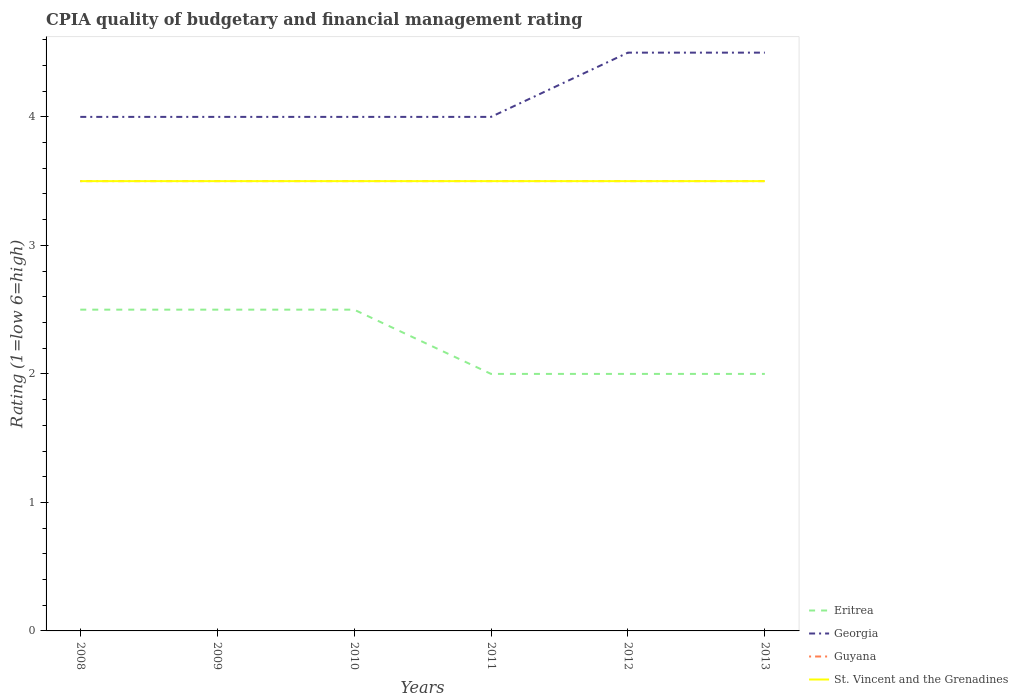How many different coloured lines are there?
Your answer should be very brief. 4. What is the total CPIA rating in Guyana in the graph?
Your response must be concise. 0. What is the difference between the highest and the lowest CPIA rating in Eritrea?
Your answer should be compact. 3. Is the CPIA rating in Guyana strictly greater than the CPIA rating in Eritrea over the years?
Keep it short and to the point. No. How many lines are there?
Keep it short and to the point. 4. Are the values on the major ticks of Y-axis written in scientific E-notation?
Offer a very short reply. No. Does the graph contain any zero values?
Your answer should be compact. No. Where does the legend appear in the graph?
Give a very brief answer. Bottom right. How many legend labels are there?
Provide a succinct answer. 4. What is the title of the graph?
Ensure brevity in your answer.  CPIA quality of budgetary and financial management rating. Does "Poland" appear as one of the legend labels in the graph?
Your answer should be very brief. No. What is the label or title of the X-axis?
Your response must be concise. Years. What is the Rating (1=low 6=high) in Eritrea in 2008?
Keep it short and to the point. 2.5. What is the Rating (1=low 6=high) of Georgia in 2008?
Keep it short and to the point. 4. What is the Rating (1=low 6=high) of Guyana in 2009?
Provide a succinct answer. 3.5. What is the Rating (1=low 6=high) of St. Vincent and the Grenadines in 2009?
Provide a succinct answer. 3.5. What is the Rating (1=low 6=high) of Eritrea in 2010?
Give a very brief answer. 2.5. What is the Rating (1=low 6=high) of Georgia in 2010?
Provide a succinct answer. 4. What is the Rating (1=low 6=high) of Guyana in 2010?
Your answer should be compact. 3.5. What is the Rating (1=low 6=high) of Eritrea in 2011?
Your answer should be very brief. 2. What is the Rating (1=low 6=high) of Guyana in 2011?
Your answer should be very brief. 3.5. What is the Rating (1=low 6=high) of St. Vincent and the Grenadines in 2012?
Offer a very short reply. 3.5. What is the Rating (1=low 6=high) of Eritrea in 2013?
Your answer should be very brief. 2. What is the Rating (1=low 6=high) in Guyana in 2013?
Keep it short and to the point. 3.5. What is the Rating (1=low 6=high) in St. Vincent and the Grenadines in 2013?
Your answer should be very brief. 3.5. Across all years, what is the maximum Rating (1=low 6=high) in Guyana?
Your response must be concise. 3.5. What is the difference between the Rating (1=low 6=high) of Georgia in 2008 and that in 2009?
Ensure brevity in your answer.  0. What is the difference between the Rating (1=low 6=high) in Guyana in 2008 and that in 2009?
Provide a succinct answer. 0. What is the difference between the Rating (1=low 6=high) in Eritrea in 2008 and that in 2010?
Provide a short and direct response. 0. What is the difference between the Rating (1=low 6=high) of Guyana in 2008 and that in 2010?
Give a very brief answer. 0. What is the difference between the Rating (1=low 6=high) of Eritrea in 2008 and that in 2011?
Provide a succinct answer. 0.5. What is the difference between the Rating (1=low 6=high) of Eritrea in 2008 and that in 2012?
Make the answer very short. 0.5. What is the difference between the Rating (1=low 6=high) in Georgia in 2008 and that in 2012?
Your answer should be compact. -0.5. What is the difference between the Rating (1=low 6=high) of Guyana in 2008 and that in 2012?
Offer a terse response. 0. What is the difference between the Rating (1=low 6=high) of St. Vincent and the Grenadines in 2008 and that in 2012?
Ensure brevity in your answer.  0. What is the difference between the Rating (1=low 6=high) in Georgia in 2008 and that in 2013?
Offer a very short reply. -0.5. What is the difference between the Rating (1=low 6=high) of Guyana in 2008 and that in 2013?
Your answer should be compact. 0. What is the difference between the Rating (1=low 6=high) in St. Vincent and the Grenadines in 2008 and that in 2013?
Your answer should be compact. 0. What is the difference between the Rating (1=low 6=high) of St. Vincent and the Grenadines in 2009 and that in 2010?
Offer a very short reply. 0. What is the difference between the Rating (1=low 6=high) in Guyana in 2009 and that in 2012?
Ensure brevity in your answer.  0. What is the difference between the Rating (1=low 6=high) of Eritrea in 2009 and that in 2013?
Provide a short and direct response. 0.5. What is the difference between the Rating (1=low 6=high) of Georgia in 2009 and that in 2013?
Ensure brevity in your answer.  -0.5. What is the difference between the Rating (1=low 6=high) in St. Vincent and the Grenadines in 2009 and that in 2013?
Offer a terse response. 0. What is the difference between the Rating (1=low 6=high) in Eritrea in 2010 and that in 2011?
Offer a terse response. 0.5. What is the difference between the Rating (1=low 6=high) in Georgia in 2010 and that in 2011?
Provide a succinct answer. 0. What is the difference between the Rating (1=low 6=high) in St. Vincent and the Grenadines in 2010 and that in 2011?
Give a very brief answer. 0. What is the difference between the Rating (1=low 6=high) of Eritrea in 2010 and that in 2012?
Provide a short and direct response. 0.5. What is the difference between the Rating (1=low 6=high) of Georgia in 2010 and that in 2012?
Offer a terse response. -0.5. What is the difference between the Rating (1=low 6=high) in St. Vincent and the Grenadines in 2010 and that in 2012?
Your answer should be very brief. 0. What is the difference between the Rating (1=low 6=high) in Guyana in 2010 and that in 2013?
Offer a terse response. 0. What is the difference between the Rating (1=low 6=high) in St. Vincent and the Grenadines in 2010 and that in 2013?
Keep it short and to the point. 0. What is the difference between the Rating (1=low 6=high) in Eritrea in 2011 and that in 2012?
Offer a very short reply. 0. What is the difference between the Rating (1=low 6=high) in Guyana in 2011 and that in 2012?
Offer a very short reply. 0. What is the difference between the Rating (1=low 6=high) of Eritrea in 2011 and that in 2013?
Offer a very short reply. 0. What is the difference between the Rating (1=low 6=high) in Georgia in 2011 and that in 2013?
Provide a short and direct response. -0.5. What is the difference between the Rating (1=low 6=high) of St. Vincent and the Grenadines in 2011 and that in 2013?
Provide a succinct answer. 0. What is the difference between the Rating (1=low 6=high) of Eritrea in 2012 and that in 2013?
Offer a terse response. 0. What is the difference between the Rating (1=low 6=high) in Georgia in 2012 and that in 2013?
Provide a succinct answer. 0. What is the difference between the Rating (1=low 6=high) of Eritrea in 2008 and the Rating (1=low 6=high) of Georgia in 2009?
Offer a terse response. -1.5. What is the difference between the Rating (1=low 6=high) in Eritrea in 2008 and the Rating (1=low 6=high) in Guyana in 2009?
Offer a very short reply. -1. What is the difference between the Rating (1=low 6=high) in Eritrea in 2008 and the Rating (1=low 6=high) in Georgia in 2010?
Provide a succinct answer. -1.5. What is the difference between the Rating (1=low 6=high) in Georgia in 2008 and the Rating (1=low 6=high) in Guyana in 2010?
Your answer should be very brief. 0.5. What is the difference between the Rating (1=low 6=high) in Georgia in 2008 and the Rating (1=low 6=high) in Guyana in 2011?
Your answer should be very brief. 0.5. What is the difference between the Rating (1=low 6=high) of Guyana in 2008 and the Rating (1=low 6=high) of St. Vincent and the Grenadines in 2011?
Provide a short and direct response. 0. What is the difference between the Rating (1=low 6=high) of Eritrea in 2008 and the Rating (1=low 6=high) of Georgia in 2012?
Your answer should be compact. -2. What is the difference between the Rating (1=low 6=high) of Eritrea in 2008 and the Rating (1=low 6=high) of St. Vincent and the Grenadines in 2012?
Provide a short and direct response. -1. What is the difference between the Rating (1=low 6=high) in Guyana in 2008 and the Rating (1=low 6=high) in St. Vincent and the Grenadines in 2012?
Offer a terse response. 0. What is the difference between the Rating (1=low 6=high) in Eritrea in 2008 and the Rating (1=low 6=high) in St. Vincent and the Grenadines in 2013?
Your answer should be compact. -1. What is the difference between the Rating (1=low 6=high) of Guyana in 2008 and the Rating (1=low 6=high) of St. Vincent and the Grenadines in 2013?
Your answer should be compact. 0. What is the difference between the Rating (1=low 6=high) in Eritrea in 2009 and the Rating (1=low 6=high) in Georgia in 2010?
Offer a terse response. -1.5. What is the difference between the Rating (1=low 6=high) in Georgia in 2009 and the Rating (1=low 6=high) in Guyana in 2010?
Keep it short and to the point. 0.5. What is the difference between the Rating (1=low 6=high) of Eritrea in 2009 and the Rating (1=low 6=high) of Guyana in 2011?
Provide a short and direct response. -1. What is the difference between the Rating (1=low 6=high) of Georgia in 2009 and the Rating (1=low 6=high) of Guyana in 2011?
Your answer should be compact. 0.5. What is the difference between the Rating (1=low 6=high) of Guyana in 2009 and the Rating (1=low 6=high) of St. Vincent and the Grenadines in 2011?
Offer a very short reply. 0. What is the difference between the Rating (1=low 6=high) in Eritrea in 2009 and the Rating (1=low 6=high) in Georgia in 2012?
Offer a terse response. -2. What is the difference between the Rating (1=low 6=high) of Eritrea in 2009 and the Rating (1=low 6=high) of Guyana in 2012?
Your answer should be compact. -1. What is the difference between the Rating (1=low 6=high) of Eritrea in 2009 and the Rating (1=low 6=high) of St. Vincent and the Grenadines in 2012?
Your answer should be compact. -1. What is the difference between the Rating (1=low 6=high) in Georgia in 2009 and the Rating (1=low 6=high) in St. Vincent and the Grenadines in 2012?
Your answer should be compact. 0.5. What is the difference between the Rating (1=low 6=high) of Guyana in 2009 and the Rating (1=low 6=high) of St. Vincent and the Grenadines in 2012?
Your answer should be compact. 0. What is the difference between the Rating (1=low 6=high) in Eritrea in 2009 and the Rating (1=low 6=high) in Georgia in 2013?
Ensure brevity in your answer.  -2. What is the difference between the Rating (1=low 6=high) of Eritrea in 2009 and the Rating (1=low 6=high) of St. Vincent and the Grenadines in 2013?
Keep it short and to the point. -1. What is the difference between the Rating (1=low 6=high) in Georgia in 2009 and the Rating (1=low 6=high) in Guyana in 2013?
Keep it short and to the point. 0.5. What is the difference between the Rating (1=low 6=high) of Georgia in 2009 and the Rating (1=low 6=high) of St. Vincent and the Grenadines in 2013?
Provide a succinct answer. 0.5. What is the difference between the Rating (1=low 6=high) of Eritrea in 2010 and the Rating (1=low 6=high) of Georgia in 2011?
Your response must be concise. -1.5. What is the difference between the Rating (1=low 6=high) in Eritrea in 2010 and the Rating (1=low 6=high) in St. Vincent and the Grenadines in 2011?
Keep it short and to the point. -1. What is the difference between the Rating (1=low 6=high) in Eritrea in 2010 and the Rating (1=low 6=high) in St. Vincent and the Grenadines in 2012?
Ensure brevity in your answer.  -1. What is the difference between the Rating (1=low 6=high) in Georgia in 2010 and the Rating (1=low 6=high) in Guyana in 2012?
Provide a short and direct response. 0.5. What is the difference between the Rating (1=low 6=high) of Georgia in 2010 and the Rating (1=low 6=high) of St. Vincent and the Grenadines in 2012?
Provide a succinct answer. 0.5. What is the difference between the Rating (1=low 6=high) in Guyana in 2010 and the Rating (1=low 6=high) in St. Vincent and the Grenadines in 2012?
Offer a very short reply. 0. What is the difference between the Rating (1=low 6=high) of Eritrea in 2010 and the Rating (1=low 6=high) of Georgia in 2013?
Provide a succinct answer. -2. What is the difference between the Rating (1=low 6=high) in Eritrea in 2010 and the Rating (1=low 6=high) in Guyana in 2013?
Offer a very short reply. -1. What is the difference between the Rating (1=low 6=high) in Georgia in 2010 and the Rating (1=low 6=high) in St. Vincent and the Grenadines in 2013?
Your answer should be very brief. 0.5. What is the difference between the Rating (1=low 6=high) of Guyana in 2010 and the Rating (1=low 6=high) of St. Vincent and the Grenadines in 2013?
Your response must be concise. 0. What is the difference between the Rating (1=low 6=high) in Georgia in 2011 and the Rating (1=low 6=high) in St. Vincent and the Grenadines in 2012?
Ensure brevity in your answer.  0.5. What is the difference between the Rating (1=low 6=high) in Eritrea in 2011 and the Rating (1=low 6=high) in Georgia in 2013?
Provide a succinct answer. -2.5. What is the difference between the Rating (1=low 6=high) in Eritrea in 2012 and the Rating (1=low 6=high) in Georgia in 2013?
Keep it short and to the point. -2.5. What is the difference between the Rating (1=low 6=high) in Eritrea in 2012 and the Rating (1=low 6=high) in Guyana in 2013?
Your answer should be very brief. -1.5. What is the difference between the Rating (1=low 6=high) of Eritrea in 2012 and the Rating (1=low 6=high) of St. Vincent and the Grenadines in 2013?
Give a very brief answer. -1.5. What is the difference between the Rating (1=low 6=high) of Guyana in 2012 and the Rating (1=low 6=high) of St. Vincent and the Grenadines in 2013?
Make the answer very short. 0. What is the average Rating (1=low 6=high) of Eritrea per year?
Provide a succinct answer. 2.25. What is the average Rating (1=low 6=high) in Georgia per year?
Give a very brief answer. 4.17. In the year 2008, what is the difference between the Rating (1=low 6=high) of Georgia and Rating (1=low 6=high) of Guyana?
Offer a very short reply. 0.5. In the year 2008, what is the difference between the Rating (1=low 6=high) of Georgia and Rating (1=low 6=high) of St. Vincent and the Grenadines?
Ensure brevity in your answer.  0.5. In the year 2008, what is the difference between the Rating (1=low 6=high) in Guyana and Rating (1=low 6=high) in St. Vincent and the Grenadines?
Your response must be concise. 0. In the year 2009, what is the difference between the Rating (1=low 6=high) of Eritrea and Rating (1=low 6=high) of Guyana?
Provide a short and direct response. -1. In the year 2009, what is the difference between the Rating (1=low 6=high) of Eritrea and Rating (1=low 6=high) of St. Vincent and the Grenadines?
Your answer should be very brief. -1. In the year 2009, what is the difference between the Rating (1=low 6=high) in Georgia and Rating (1=low 6=high) in Guyana?
Your answer should be very brief. 0.5. In the year 2009, what is the difference between the Rating (1=low 6=high) in Guyana and Rating (1=low 6=high) in St. Vincent and the Grenadines?
Your answer should be very brief. 0. In the year 2010, what is the difference between the Rating (1=low 6=high) in Eritrea and Rating (1=low 6=high) in Georgia?
Give a very brief answer. -1.5. In the year 2010, what is the difference between the Rating (1=low 6=high) of Eritrea and Rating (1=low 6=high) of St. Vincent and the Grenadines?
Give a very brief answer. -1. In the year 2010, what is the difference between the Rating (1=low 6=high) in Georgia and Rating (1=low 6=high) in St. Vincent and the Grenadines?
Provide a short and direct response. 0.5. In the year 2010, what is the difference between the Rating (1=low 6=high) in Guyana and Rating (1=low 6=high) in St. Vincent and the Grenadines?
Ensure brevity in your answer.  0. In the year 2011, what is the difference between the Rating (1=low 6=high) in Eritrea and Rating (1=low 6=high) in Georgia?
Provide a succinct answer. -2. In the year 2011, what is the difference between the Rating (1=low 6=high) of Eritrea and Rating (1=low 6=high) of St. Vincent and the Grenadines?
Offer a very short reply. -1.5. In the year 2011, what is the difference between the Rating (1=low 6=high) in Georgia and Rating (1=low 6=high) in St. Vincent and the Grenadines?
Give a very brief answer. 0.5. In the year 2011, what is the difference between the Rating (1=low 6=high) of Guyana and Rating (1=low 6=high) of St. Vincent and the Grenadines?
Provide a short and direct response. 0. In the year 2012, what is the difference between the Rating (1=low 6=high) of Eritrea and Rating (1=low 6=high) of St. Vincent and the Grenadines?
Offer a very short reply. -1.5. In the year 2012, what is the difference between the Rating (1=low 6=high) in Guyana and Rating (1=low 6=high) in St. Vincent and the Grenadines?
Keep it short and to the point. 0. In the year 2013, what is the difference between the Rating (1=low 6=high) in Eritrea and Rating (1=low 6=high) in Georgia?
Your answer should be very brief. -2.5. In the year 2013, what is the difference between the Rating (1=low 6=high) in Eritrea and Rating (1=low 6=high) in Guyana?
Your answer should be compact. -1.5. In the year 2013, what is the difference between the Rating (1=low 6=high) of Georgia and Rating (1=low 6=high) of Guyana?
Ensure brevity in your answer.  1. In the year 2013, what is the difference between the Rating (1=low 6=high) in Georgia and Rating (1=low 6=high) in St. Vincent and the Grenadines?
Offer a terse response. 1. What is the ratio of the Rating (1=low 6=high) in Eritrea in 2008 to that in 2009?
Make the answer very short. 1. What is the ratio of the Rating (1=low 6=high) in Georgia in 2008 to that in 2009?
Offer a terse response. 1. What is the ratio of the Rating (1=low 6=high) in Guyana in 2008 to that in 2009?
Your response must be concise. 1. What is the ratio of the Rating (1=low 6=high) of St. Vincent and the Grenadines in 2008 to that in 2009?
Keep it short and to the point. 1. What is the ratio of the Rating (1=low 6=high) in Georgia in 2008 to that in 2010?
Your response must be concise. 1. What is the ratio of the Rating (1=low 6=high) of Guyana in 2008 to that in 2010?
Provide a succinct answer. 1. What is the ratio of the Rating (1=low 6=high) in St. Vincent and the Grenadines in 2008 to that in 2011?
Offer a terse response. 1. What is the ratio of the Rating (1=low 6=high) of Eritrea in 2008 to that in 2012?
Your answer should be compact. 1.25. What is the ratio of the Rating (1=low 6=high) in Georgia in 2008 to that in 2012?
Provide a succinct answer. 0.89. What is the ratio of the Rating (1=low 6=high) in St. Vincent and the Grenadines in 2008 to that in 2012?
Offer a terse response. 1. What is the ratio of the Rating (1=low 6=high) in Guyana in 2008 to that in 2013?
Your answer should be very brief. 1. What is the ratio of the Rating (1=low 6=high) of Georgia in 2009 to that in 2010?
Ensure brevity in your answer.  1. What is the ratio of the Rating (1=low 6=high) of Guyana in 2009 to that in 2010?
Your response must be concise. 1. What is the ratio of the Rating (1=low 6=high) of Eritrea in 2009 to that in 2011?
Your response must be concise. 1.25. What is the ratio of the Rating (1=low 6=high) of Guyana in 2009 to that in 2011?
Your answer should be very brief. 1. What is the ratio of the Rating (1=low 6=high) of St. Vincent and the Grenadines in 2009 to that in 2011?
Ensure brevity in your answer.  1. What is the ratio of the Rating (1=low 6=high) in Guyana in 2009 to that in 2013?
Offer a very short reply. 1. What is the ratio of the Rating (1=low 6=high) in St. Vincent and the Grenadines in 2009 to that in 2013?
Offer a terse response. 1. What is the ratio of the Rating (1=low 6=high) of Eritrea in 2010 to that in 2011?
Offer a very short reply. 1.25. What is the ratio of the Rating (1=low 6=high) in Georgia in 2010 to that in 2011?
Give a very brief answer. 1. What is the ratio of the Rating (1=low 6=high) in Guyana in 2010 to that in 2011?
Offer a terse response. 1. What is the ratio of the Rating (1=low 6=high) of St. Vincent and the Grenadines in 2010 to that in 2011?
Your answer should be very brief. 1. What is the ratio of the Rating (1=low 6=high) of Georgia in 2010 to that in 2012?
Provide a succinct answer. 0.89. What is the ratio of the Rating (1=low 6=high) in Eritrea in 2010 to that in 2013?
Ensure brevity in your answer.  1.25. What is the ratio of the Rating (1=low 6=high) of Guyana in 2010 to that in 2013?
Offer a very short reply. 1. What is the ratio of the Rating (1=low 6=high) in St. Vincent and the Grenadines in 2010 to that in 2013?
Your answer should be very brief. 1. What is the ratio of the Rating (1=low 6=high) in St. Vincent and the Grenadines in 2011 to that in 2012?
Ensure brevity in your answer.  1. What is the ratio of the Rating (1=low 6=high) of Eritrea in 2011 to that in 2013?
Keep it short and to the point. 1. What is the ratio of the Rating (1=low 6=high) of Eritrea in 2012 to that in 2013?
Provide a short and direct response. 1. What is the ratio of the Rating (1=low 6=high) of Georgia in 2012 to that in 2013?
Offer a very short reply. 1. What is the ratio of the Rating (1=low 6=high) in St. Vincent and the Grenadines in 2012 to that in 2013?
Ensure brevity in your answer.  1. What is the difference between the highest and the second highest Rating (1=low 6=high) in Eritrea?
Your answer should be very brief. 0. What is the difference between the highest and the second highest Rating (1=low 6=high) of Georgia?
Provide a succinct answer. 0. What is the difference between the highest and the second highest Rating (1=low 6=high) in St. Vincent and the Grenadines?
Ensure brevity in your answer.  0. What is the difference between the highest and the lowest Rating (1=low 6=high) of Guyana?
Provide a succinct answer. 0. 